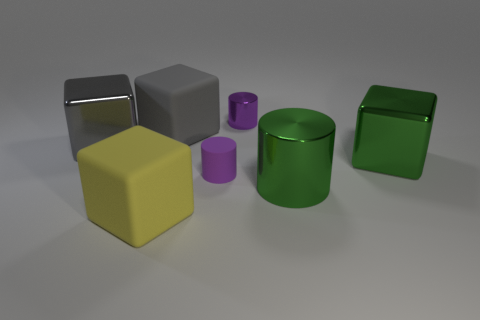Is there a block left of the big shiny thing that is to the left of the purple shiny thing?
Your answer should be compact. No. Is the number of gray rubber cubes to the left of the gray rubber block less than the number of objects on the left side of the small purple metallic object?
Keep it short and to the point. Yes. What is the size of the shiny cylinder behind the big green shiny object in front of the metal block on the right side of the big gray rubber object?
Provide a succinct answer. Small. There is a purple cylinder that is behind the gray matte thing; is it the same size as the gray shiny cube?
Your response must be concise. No. What number of other objects are there of the same material as the big yellow thing?
Your answer should be compact. 2. Is the number of green blocks greater than the number of small purple things?
Your answer should be compact. No. The green object that is behind the big shiny thing that is in front of the big green metal thing that is on the right side of the big green shiny cylinder is made of what material?
Your response must be concise. Metal. Is the large shiny cylinder the same color as the small matte cylinder?
Your answer should be compact. No. Are there any matte objects that have the same color as the small metallic cylinder?
Offer a terse response. Yes. What is the shape of the purple metal thing that is the same size as the purple matte cylinder?
Your answer should be very brief. Cylinder. 